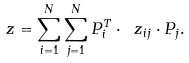<formula> <loc_0><loc_0><loc_500><loc_500>\ z = \sum _ { i = 1 } ^ { N } \sum _ { j = 1 } ^ { N } P _ { i } ^ { T } \cdot \ z _ { i j } \cdot P _ { j } .</formula> 